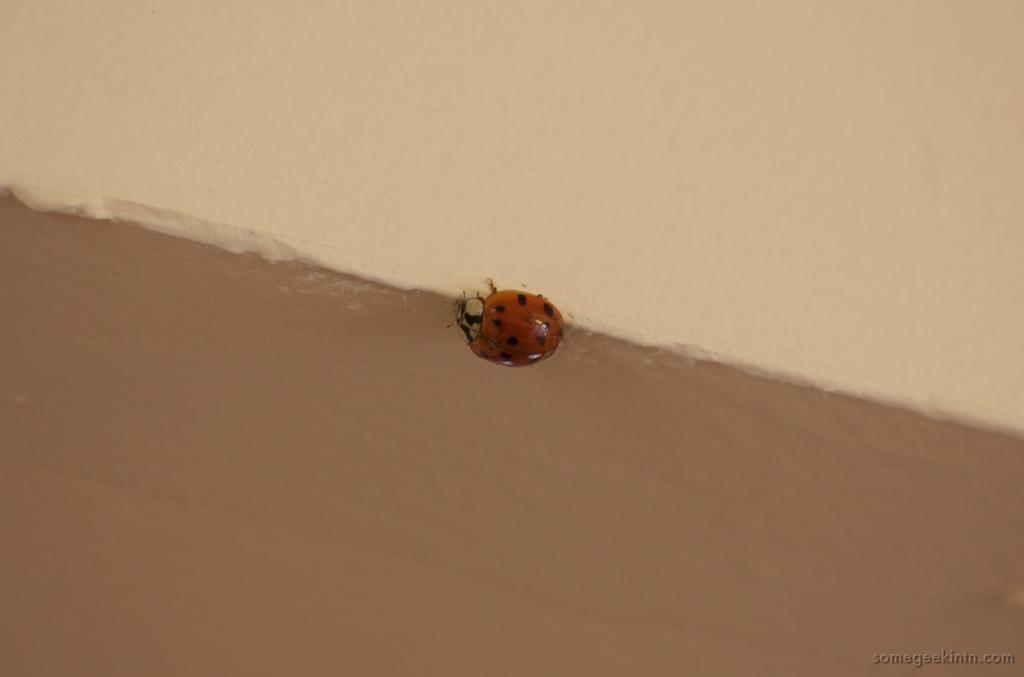How would you summarize this image in a sentence or two? In the image there is a bug on the wall with brown painting below and cream painting above. 